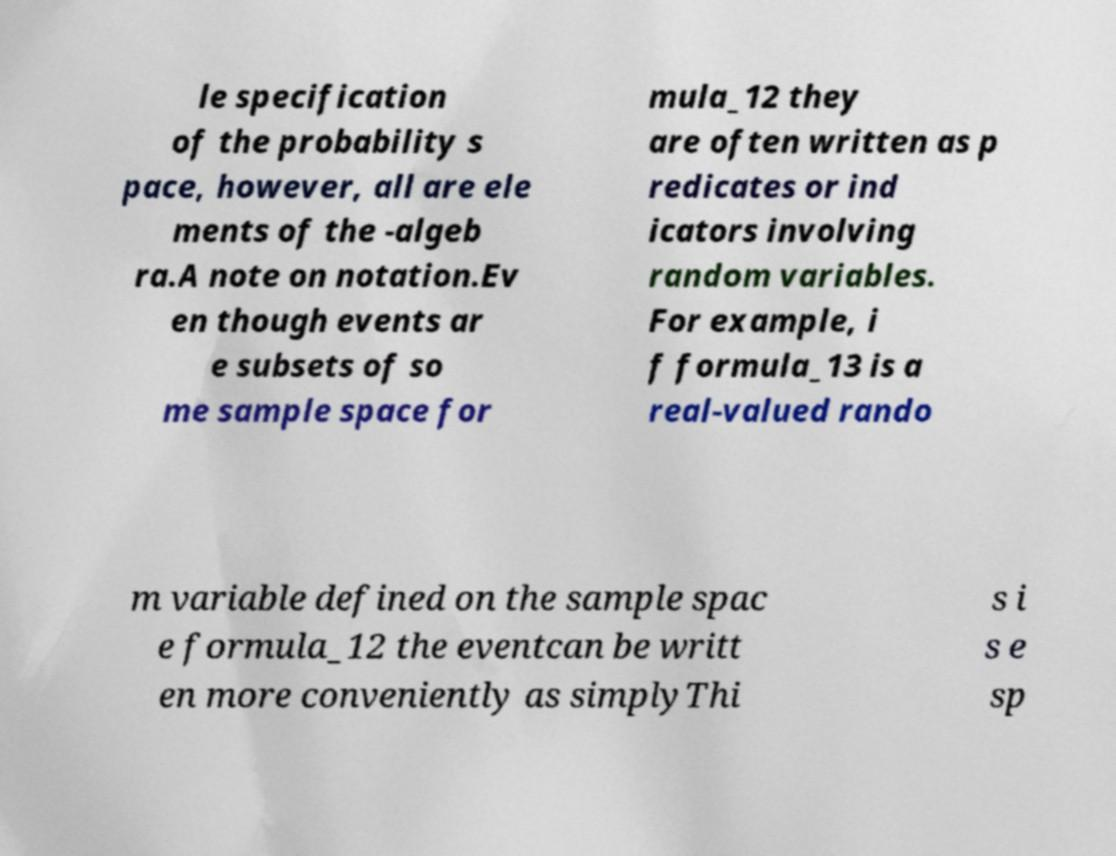I need the written content from this picture converted into text. Can you do that? le specification of the probability s pace, however, all are ele ments of the -algeb ra.A note on notation.Ev en though events ar e subsets of so me sample space for mula_12 they are often written as p redicates or ind icators involving random variables. For example, i f formula_13 is a real-valued rando m variable defined on the sample spac e formula_12 the eventcan be writt en more conveniently as simplyThi s i s e sp 